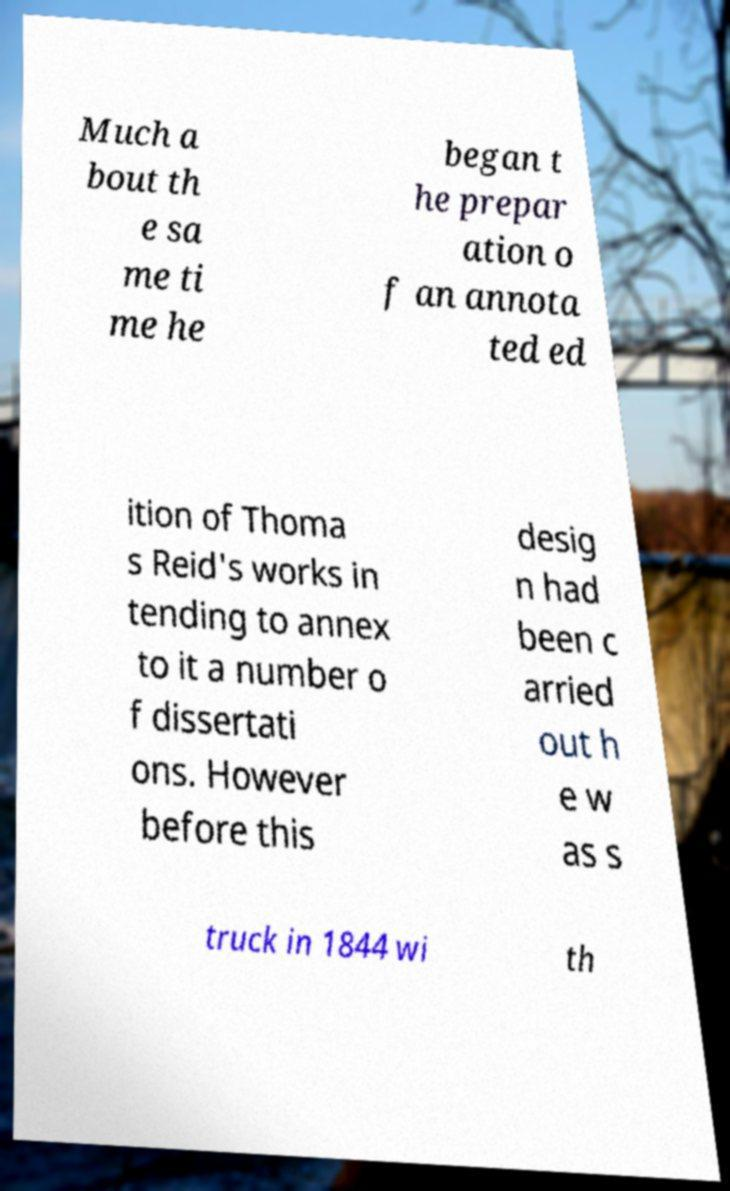What messages or text are displayed in this image? I need them in a readable, typed format. Much a bout th e sa me ti me he began t he prepar ation o f an annota ted ed ition of Thoma s Reid's works in tending to annex to it a number o f dissertati ons. However before this desig n had been c arried out h e w as s truck in 1844 wi th 